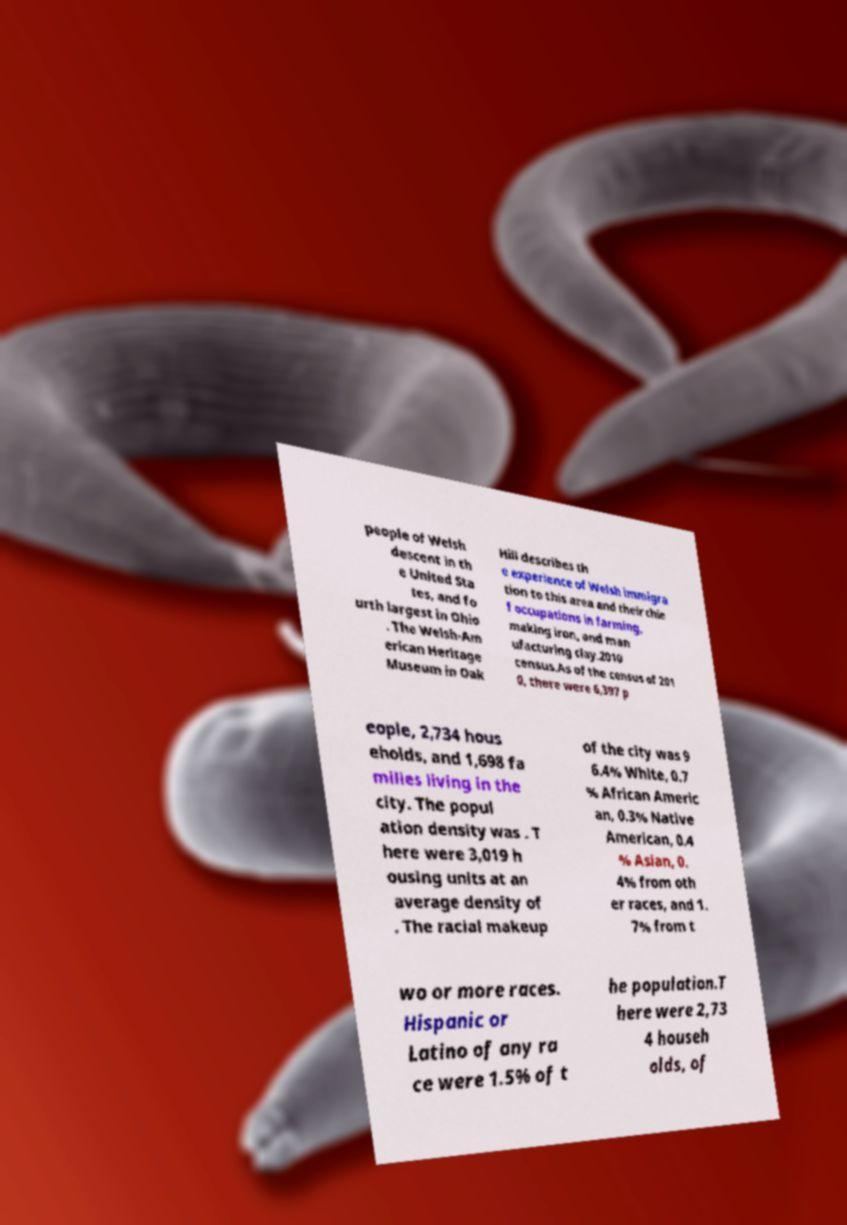Can you accurately transcribe the text from the provided image for me? people of Welsh descent in th e United Sta tes, and fo urth largest in Ohio . The Welsh-Am erican Heritage Museum in Oak Hill describes th e experience of Welsh immigra tion to this area and their chie f occupations in farming, making iron, and man ufacturing clay.2010 census.As of the census of 201 0, there were 6,397 p eople, 2,734 hous eholds, and 1,698 fa milies living in the city. The popul ation density was . T here were 3,019 h ousing units at an average density of . The racial makeup of the city was 9 6.4% White, 0.7 % African Americ an, 0.3% Native American, 0.4 % Asian, 0. 4% from oth er races, and 1. 7% from t wo or more races. Hispanic or Latino of any ra ce were 1.5% of t he population.T here were 2,73 4 househ olds, of 